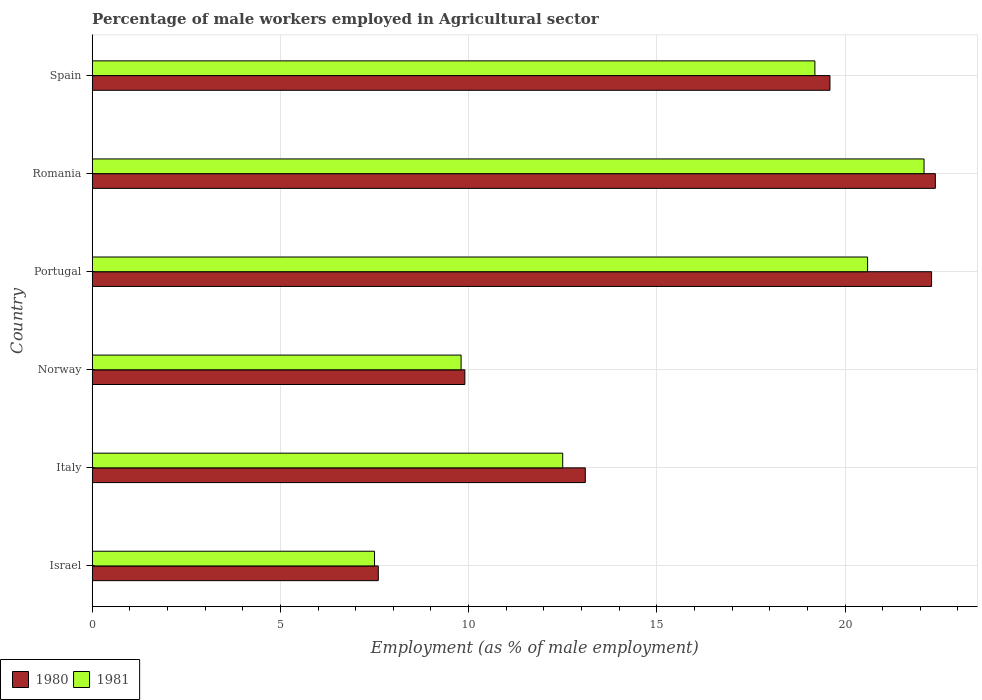How many different coloured bars are there?
Offer a terse response. 2. Are the number of bars per tick equal to the number of legend labels?
Offer a very short reply. Yes. Are the number of bars on each tick of the Y-axis equal?
Provide a succinct answer. Yes. What is the percentage of male workers employed in Agricultural sector in 1980 in Romania?
Offer a very short reply. 22.4. Across all countries, what is the maximum percentage of male workers employed in Agricultural sector in 1980?
Provide a short and direct response. 22.4. In which country was the percentage of male workers employed in Agricultural sector in 1980 maximum?
Your response must be concise. Romania. What is the total percentage of male workers employed in Agricultural sector in 1981 in the graph?
Your answer should be very brief. 91.7. What is the difference between the percentage of male workers employed in Agricultural sector in 1980 in Italy and that in Spain?
Your answer should be compact. -6.5. What is the difference between the percentage of male workers employed in Agricultural sector in 1981 in Portugal and the percentage of male workers employed in Agricultural sector in 1980 in Norway?
Offer a very short reply. 10.7. What is the average percentage of male workers employed in Agricultural sector in 1980 per country?
Provide a succinct answer. 15.82. What is the difference between the percentage of male workers employed in Agricultural sector in 1981 and percentage of male workers employed in Agricultural sector in 1980 in Spain?
Offer a terse response. -0.4. What is the ratio of the percentage of male workers employed in Agricultural sector in 1981 in Italy to that in Romania?
Your answer should be very brief. 0.57. Is the percentage of male workers employed in Agricultural sector in 1980 in Israel less than that in Portugal?
Provide a succinct answer. Yes. What is the difference between the highest and the second highest percentage of male workers employed in Agricultural sector in 1980?
Provide a short and direct response. 0.1. What is the difference between the highest and the lowest percentage of male workers employed in Agricultural sector in 1981?
Provide a short and direct response. 14.6. In how many countries, is the percentage of male workers employed in Agricultural sector in 1981 greater than the average percentage of male workers employed in Agricultural sector in 1981 taken over all countries?
Ensure brevity in your answer.  3. How many bars are there?
Make the answer very short. 12. Are all the bars in the graph horizontal?
Keep it short and to the point. Yes. How many countries are there in the graph?
Your answer should be compact. 6. What is the difference between two consecutive major ticks on the X-axis?
Provide a short and direct response. 5. Does the graph contain grids?
Offer a very short reply. Yes. Where does the legend appear in the graph?
Make the answer very short. Bottom left. How many legend labels are there?
Provide a short and direct response. 2. How are the legend labels stacked?
Your answer should be compact. Horizontal. What is the title of the graph?
Ensure brevity in your answer.  Percentage of male workers employed in Agricultural sector. What is the label or title of the X-axis?
Offer a very short reply. Employment (as % of male employment). What is the Employment (as % of male employment) in 1980 in Israel?
Your response must be concise. 7.6. What is the Employment (as % of male employment) of 1981 in Israel?
Your response must be concise. 7.5. What is the Employment (as % of male employment) in 1980 in Italy?
Ensure brevity in your answer.  13.1. What is the Employment (as % of male employment) in 1980 in Norway?
Your response must be concise. 9.9. What is the Employment (as % of male employment) in 1981 in Norway?
Provide a short and direct response. 9.8. What is the Employment (as % of male employment) of 1980 in Portugal?
Your answer should be compact. 22.3. What is the Employment (as % of male employment) of 1981 in Portugal?
Your answer should be very brief. 20.6. What is the Employment (as % of male employment) in 1980 in Romania?
Give a very brief answer. 22.4. What is the Employment (as % of male employment) in 1981 in Romania?
Your answer should be very brief. 22.1. What is the Employment (as % of male employment) in 1980 in Spain?
Your answer should be compact. 19.6. What is the Employment (as % of male employment) of 1981 in Spain?
Give a very brief answer. 19.2. Across all countries, what is the maximum Employment (as % of male employment) of 1980?
Make the answer very short. 22.4. Across all countries, what is the maximum Employment (as % of male employment) in 1981?
Give a very brief answer. 22.1. Across all countries, what is the minimum Employment (as % of male employment) of 1980?
Your answer should be compact. 7.6. What is the total Employment (as % of male employment) in 1980 in the graph?
Give a very brief answer. 94.9. What is the total Employment (as % of male employment) of 1981 in the graph?
Keep it short and to the point. 91.7. What is the difference between the Employment (as % of male employment) of 1981 in Israel and that in Italy?
Your answer should be very brief. -5. What is the difference between the Employment (as % of male employment) in 1980 in Israel and that in Norway?
Offer a very short reply. -2.3. What is the difference between the Employment (as % of male employment) of 1981 in Israel and that in Norway?
Your answer should be compact. -2.3. What is the difference between the Employment (as % of male employment) of 1980 in Israel and that in Portugal?
Your answer should be very brief. -14.7. What is the difference between the Employment (as % of male employment) in 1981 in Israel and that in Portugal?
Ensure brevity in your answer.  -13.1. What is the difference between the Employment (as % of male employment) of 1980 in Israel and that in Romania?
Your answer should be very brief. -14.8. What is the difference between the Employment (as % of male employment) in 1981 in Israel and that in Romania?
Give a very brief answer. -14.6. What is the difference between the Employment (as % of male employment) in 1980 in Israel and that in Spain?
Provide a succinct answer. -12. What is the difference between the Employment (as % of male employment) of 1981 in Israel and that in Spain?
Ensure brevity in your answer.  -11.7. What is the difference between the Employment (as % of male employment) of 1980 in Italy and that in Norway?
Your response must be concise. 3.2. What is the difference between the Employment (as % of male employment) of 1981 in Italy and that in Romania?
Offer a terse response. -9.6. What is the difference between the Employment (as % of male employment) of 1980 in Italy and that in Spain?
Keep it short and to the point. -6.5. What is the difference between the Employment (as % of male employment) in 1981 in Italy and that in Spain?
Make the answer very short. -6.7. What is the difference between the Employment (as % of male employment) in 1980 in Norway and that in Romania?
Keep it short and to the point. -12.5. What is the difference between the Employment (as % of male employment) in 1981 in Norway and that in Romania?
Ensure brevity in your answer.  -12.3. What is the difference between the Employment (as % of male employment) in 1980 in Norway and that in Spain?
Give a very brief answer. -9.7. What is the difference between the Employment (as % of male employment) of 1981 in Portugal and that in Romania?
Your answer should be compact. -1.5. What is the difference between the Employment (as % of male employment) in 1980 in Portugal and that in Spain?
Offer a very short reply. 2.7. What is the difference between the Employment (as % of male employment) in 1980 in Romania and that in Spain?
Offer a terse response. 2.8. What is the difference between the Employment (as % of male employment) in 1981 in Romania and that in Spain?
Your answer should be very brief. 2.9. What is the difference between the Employment (as % of male employment) in 1980 in Israel and the Employment (as % of male employment) in 1981 in Italy?
Ensure brevity in your answer.  -4.9. What is the difference between the Employment (as % of male employment) in 1980 in Israel and the Employment (as % of male employment) in 1981 in Norway?
Offer a very short reply. -2.2. What is the difference between the Employment (as % of male employment) in 1980 in Italy and the Employment (as % of male employment) in 1981 in Spain?
Offer a terse response. -6.1. What is the difference between the Employment (as % of male employment) in 1980 in Norway and the Employment (as % of male employment) in 1981 in Portugal?
Keep it short and to the point. -10.7. What is the difference between the Employment (as % of male employment) of 1980 in Norway and the Employment (as % of male employment) of 1981 in Spain?
Offer a very short reply. -9.3. What is the difference between the Employment (as % of male employment) in 1980 in Portugal and the Employment (as % of male employment) in 1981 in Romania?
Give a very brief answer. 0.2. What is the difference between the Employment (as % of male employment) in 1980 in Portugal and the Employment (as % of male employment) in 1981 in Spain?
Keep it short and to the point. 3.1. What is the difference between the Employment (as % of male employment) in 1980 in Romania and the Employment (as % of male employment) in 1981 in Spain?
Offer a terse response. 3.2. What is the average Employment (as % of male employment) in 1980 per country?
Your response must be concise. 15.82. What is the average Employment (as % of male employment) of 1981 per country?
Offer a terse response. 15.28. What is the difference between the Employment (as % of male employment) in 1980 and Employment (as % of male employment) in 1981 in Spain?
Offer a terse response. 0.4. What is the ratio of the Employment (as % of male employment) of 1980 in Israel to that in Italy?
Your response must be concise. 0.58. What is the ratio of the Employment (as % of male employment) of 1980 in Israel to that in Norway?
Provide a succinct answer. 0.77. What is the ratio of the Employment (as % of male employment) of 1981 in Israel to that in Norway?
Your response must be concise. 0.77. What is the ratio of the Employment (as % of male employment) in 1980 in Israel to that in Portugal?
Provide a succinct answer. 0.34. What is the ratio of the Employment (as % of male employment) of 1981 in Israel to that in Portugal?
Provide a succinct answer. 0.36. What is the ratio of the Employment (as % of male employment) of 1980 in Israel to that in Romania?
Offer a terse response. 0.34. What is the ratio of the Employment (as % of male employment) of 1981 in Israel to that in Romania?
Ensure brevity in your answer.  0.34. What is the ratio of the Employment (as % of male employment) of 1980 in Israel to that in Spain?
Your response must be concise. 0.39. What is the ratio of the Employment (as % of male employment) of 1981 in Israel to that in Spain?
Give a very brief answer. 0.39. What is the ratio of the Employment (as % of male employment) in 1980 in Italy to that in Norway?
Provide a short and direct response. 1.32. What is the ratio of the Employment (as % of male employment) of 1981 in Italy to that in Norway?
Your response must be concise. 1.28. What is the ratio of the Employment (as % of male employment) of 1980 in Italy to that in Portugal?
Offer a very short reply. 0.59. What is the ratio of the Employment (as % of male employment) of 1981 in Italy to that in Portugal?
Make the answer very short. 0.61. What is the ratio of the Employment (as % of male employment) in 1980 in Italy to that in Romania?
Your response must be concise. 0.58. What is the ratio of the Employment (as % of male employment) of 1981 in Italy to that in Romania?
Your answer should be compact. 0.57. What is the ratio of the Employment (as % of male employment) of 1980 in Italy to that in Spain?
Offer a very short reply. 0.67. What is the ratio of the Employment (as % of male employment) in 1981 in Italy to that in Spain?
Offer a terse response. 0.65. What is the ratio of the Employment (as % of male employment) in 1980 in Norway to that in Portugal?
Your answer should be compact. 0.44. What is the ratio of the Employment (as % of male employment) of 1981 in Norway to that in Portugal?
Your answer should be very brief. 0.48. What is the ratio of the Employment (as % of male employment) of 1980 in Norway to that in Romania?
Your response must be concise. 0.44. What is the ratio of the Employment (as % of male employment) of 1981 in Norway to that in Romania?
Make the answer very short. 0.44. What is the ratio of the Employment (as % of male employment) in 1980 in Norway to that in Spain?
Your answer should be very brief. 0.51. What is the ratio of the Employment (as % of male employment) of 1981 in Norway to that in Spain?
Make the answer very short. 0.51. What is the ratio of the Employment (as % of male employment) of 1980 in Portugal to that in Romania?
Offer a very short reply. 1. What is the ratio of the Employment (as % of male employment) in 1981 in Portugal to that in Romania?
Keep it short and to the point. 0.93. What is the ratio of the Employment (as % of male employment) in 1980 in Portugal to that in Spain?
Offer a very short reply. 1.14. What is the ratio of the Employment (as % of male employment) of 1981 in Portugal to that in Spain?
Your answer should be very brief. 1.07. What is the ratio of the Employment (as % of male employment) of 1980 in Romania to that in Spain?
Offer a very short reply. 1.14. What is the ratio of the Employment (as % of male employment) of 1981 in Romania to that in Spain?
Provide a short and direct response. 1.15. What is the difference between the highest and the second highest Employment (as % of male employment) of 1980?
Make the answer very short. 0.1. What is the difference between the highest and the second highest Employment (as % of male employment) of 1981?
Offer a terse response. 1.5. What is the difference between the highest and the lowest Employment (as % of male employment) in 1980?
Give a very brief answer. 14.8. What is the difference between the highest and the lowest Employment (as % of male employment) in 1981?
Provide a succinct answer. 14.6. 